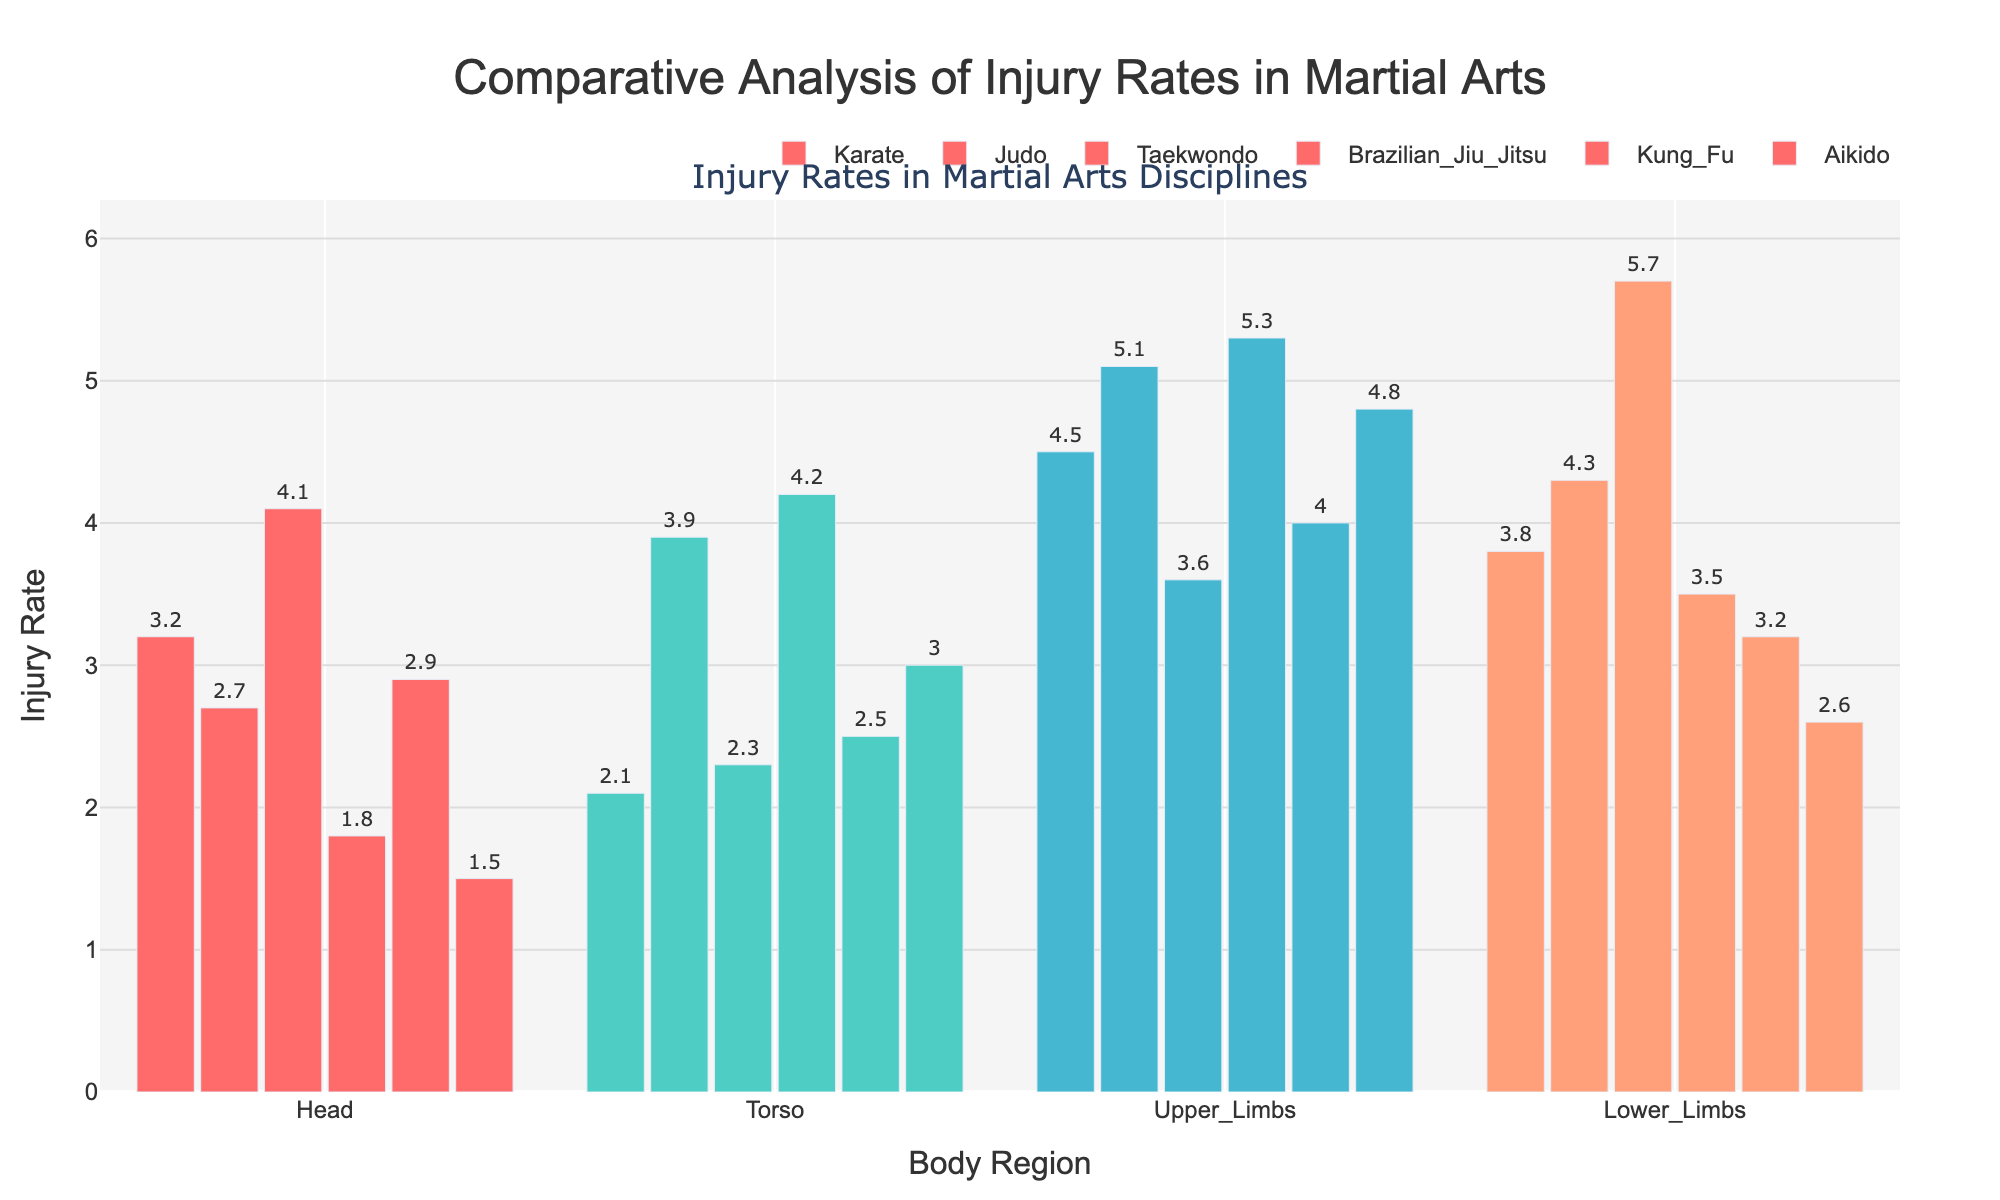What is the title of the figure? The title is located at the top center of the figure and is written in large text.
Answer: Comparative Analysis of Injury Rates in Martial Arts Which martial art discipline has the highest injury rate for the lower limbs? By referring to the bar heights for the lower limbs body region across all disciplines, we can see that Taekwondo has the highest bar.
Answer: Taekwondo How many body regions are analyzed in this figure? By counting the x-axis labels, we can see four distinct body regions.
Answer: Four Which discipline has the lowest injury rate for the head region? Comparing the bar heights for the head region across all disciplines, Aikido has the shortest bar.
Answer: Aikido What is the injury rate for the torso in Brazilian Jiu-Jitsu? Look at the bar corresponding to the torso for Brazilian Jiu-Jitsu. The height of the bar represents the injury rate.
Answer: 4.2 Between Karate and Judo, which discipline has a higher injury rate for the upper limbs? Comparing the bar heights for the upper limbs between Karate and Judo, Judo has a higher bar.
Answer: Judo What is the average injury rate for the head region across all disciplines? Add the injury rates for the head in all disciplines and divide by the number of disciplines: (3.2 + 2.7 + 4.1 + 1.8 + 2.9 + 1.5) / 6 = 16.2 / 6.
Answer: 2.7 Is the injury rate for the lower limbs in Kung Fu higher or lower than in Aikido? Compare the bar heights for the lower limbs between Kung Fu and Aikido. Kung Fu has a higher bar.
Answer: Higher Which body region has the most varying injury rates across different disciplines? Looking at the bars for each body region, observe which region shows the greatest difference in bar heights. The lower limbs region shows the most variation.
Answer: Lower Limbs Which martial art has the most even distribution of injury rates across all body regions? By comparing the bars across all disciplines, look for the discipline where the bar heights are the closest to each other within that discipline. Aikido has the most even distribution.
Answer: Aikido 